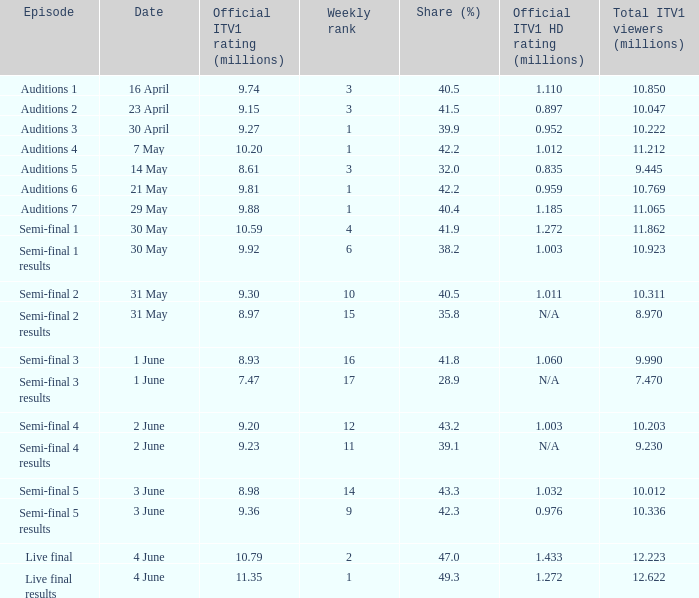For which episode was the official itv1 hd rating recorded as 1.185 million? Auditions 7. 